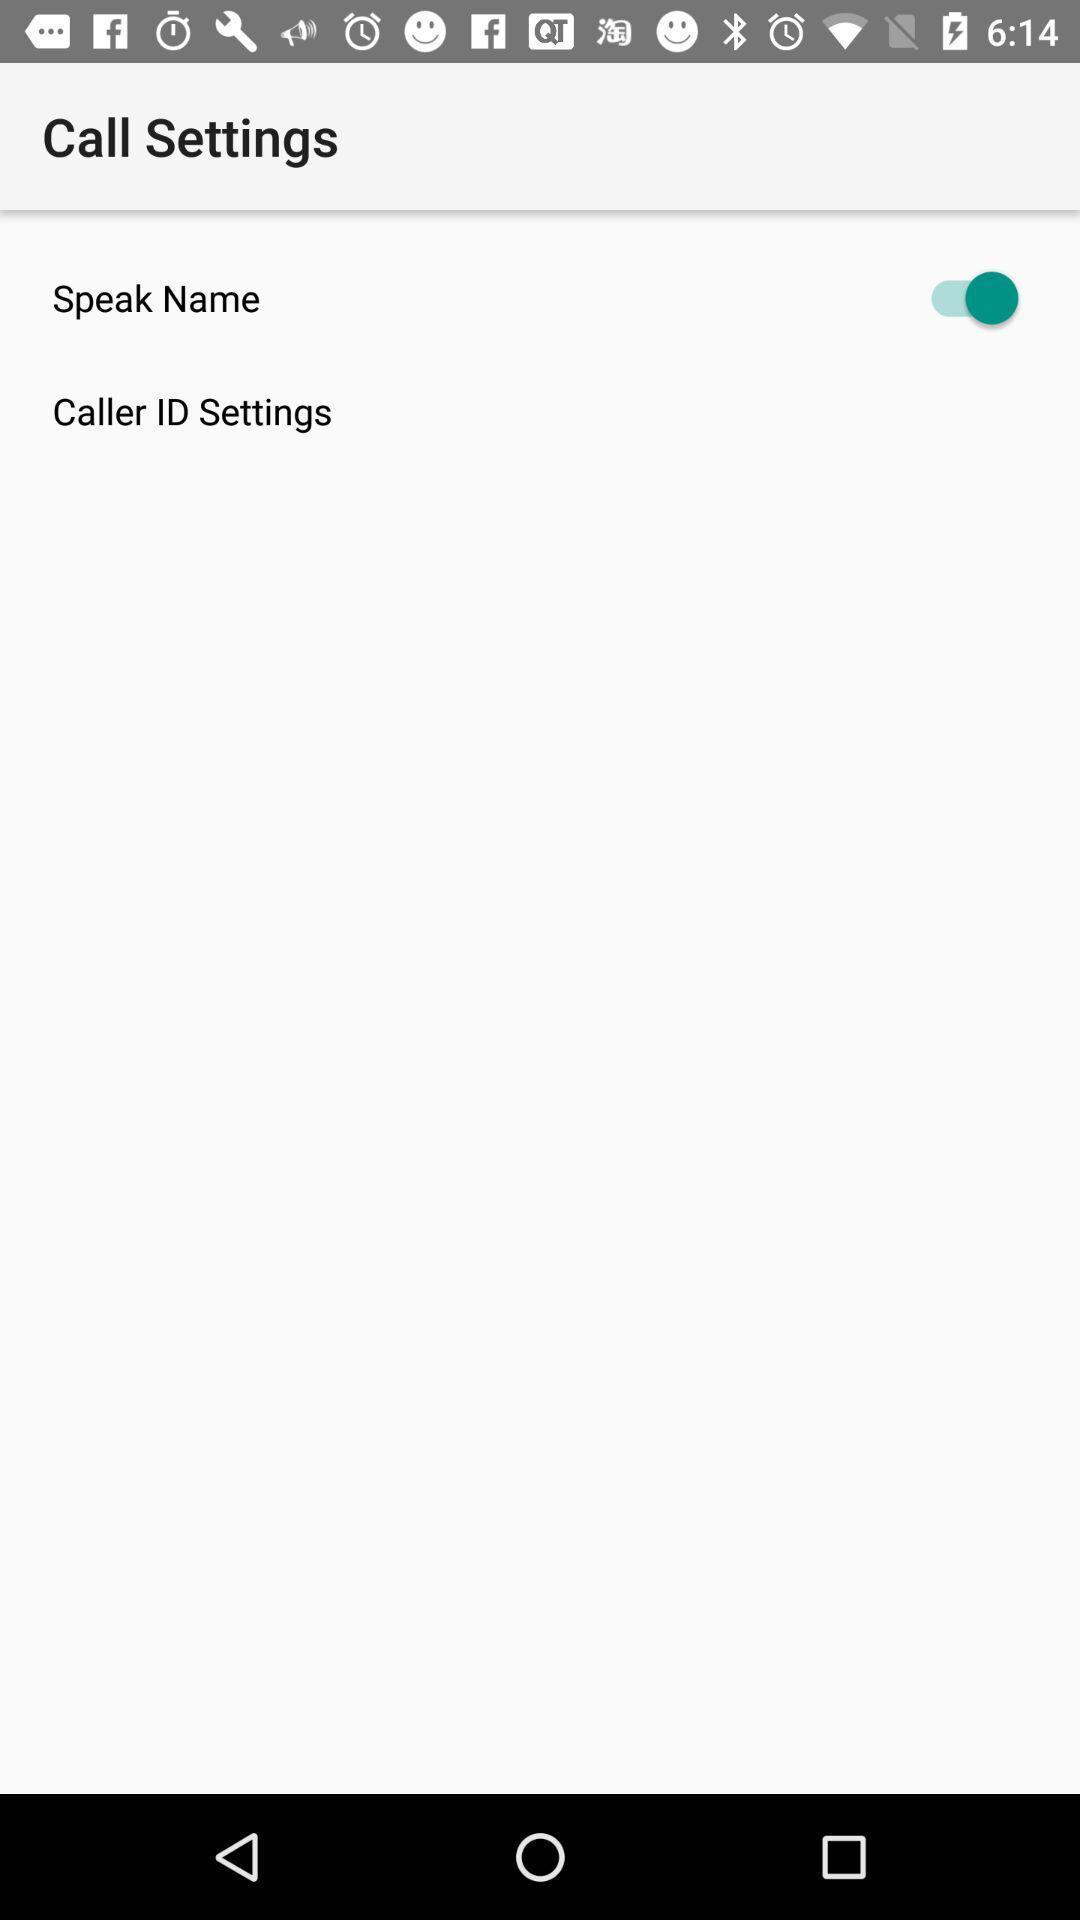Explain what's happening in this screen capture. Page showing call setting options on an app. 